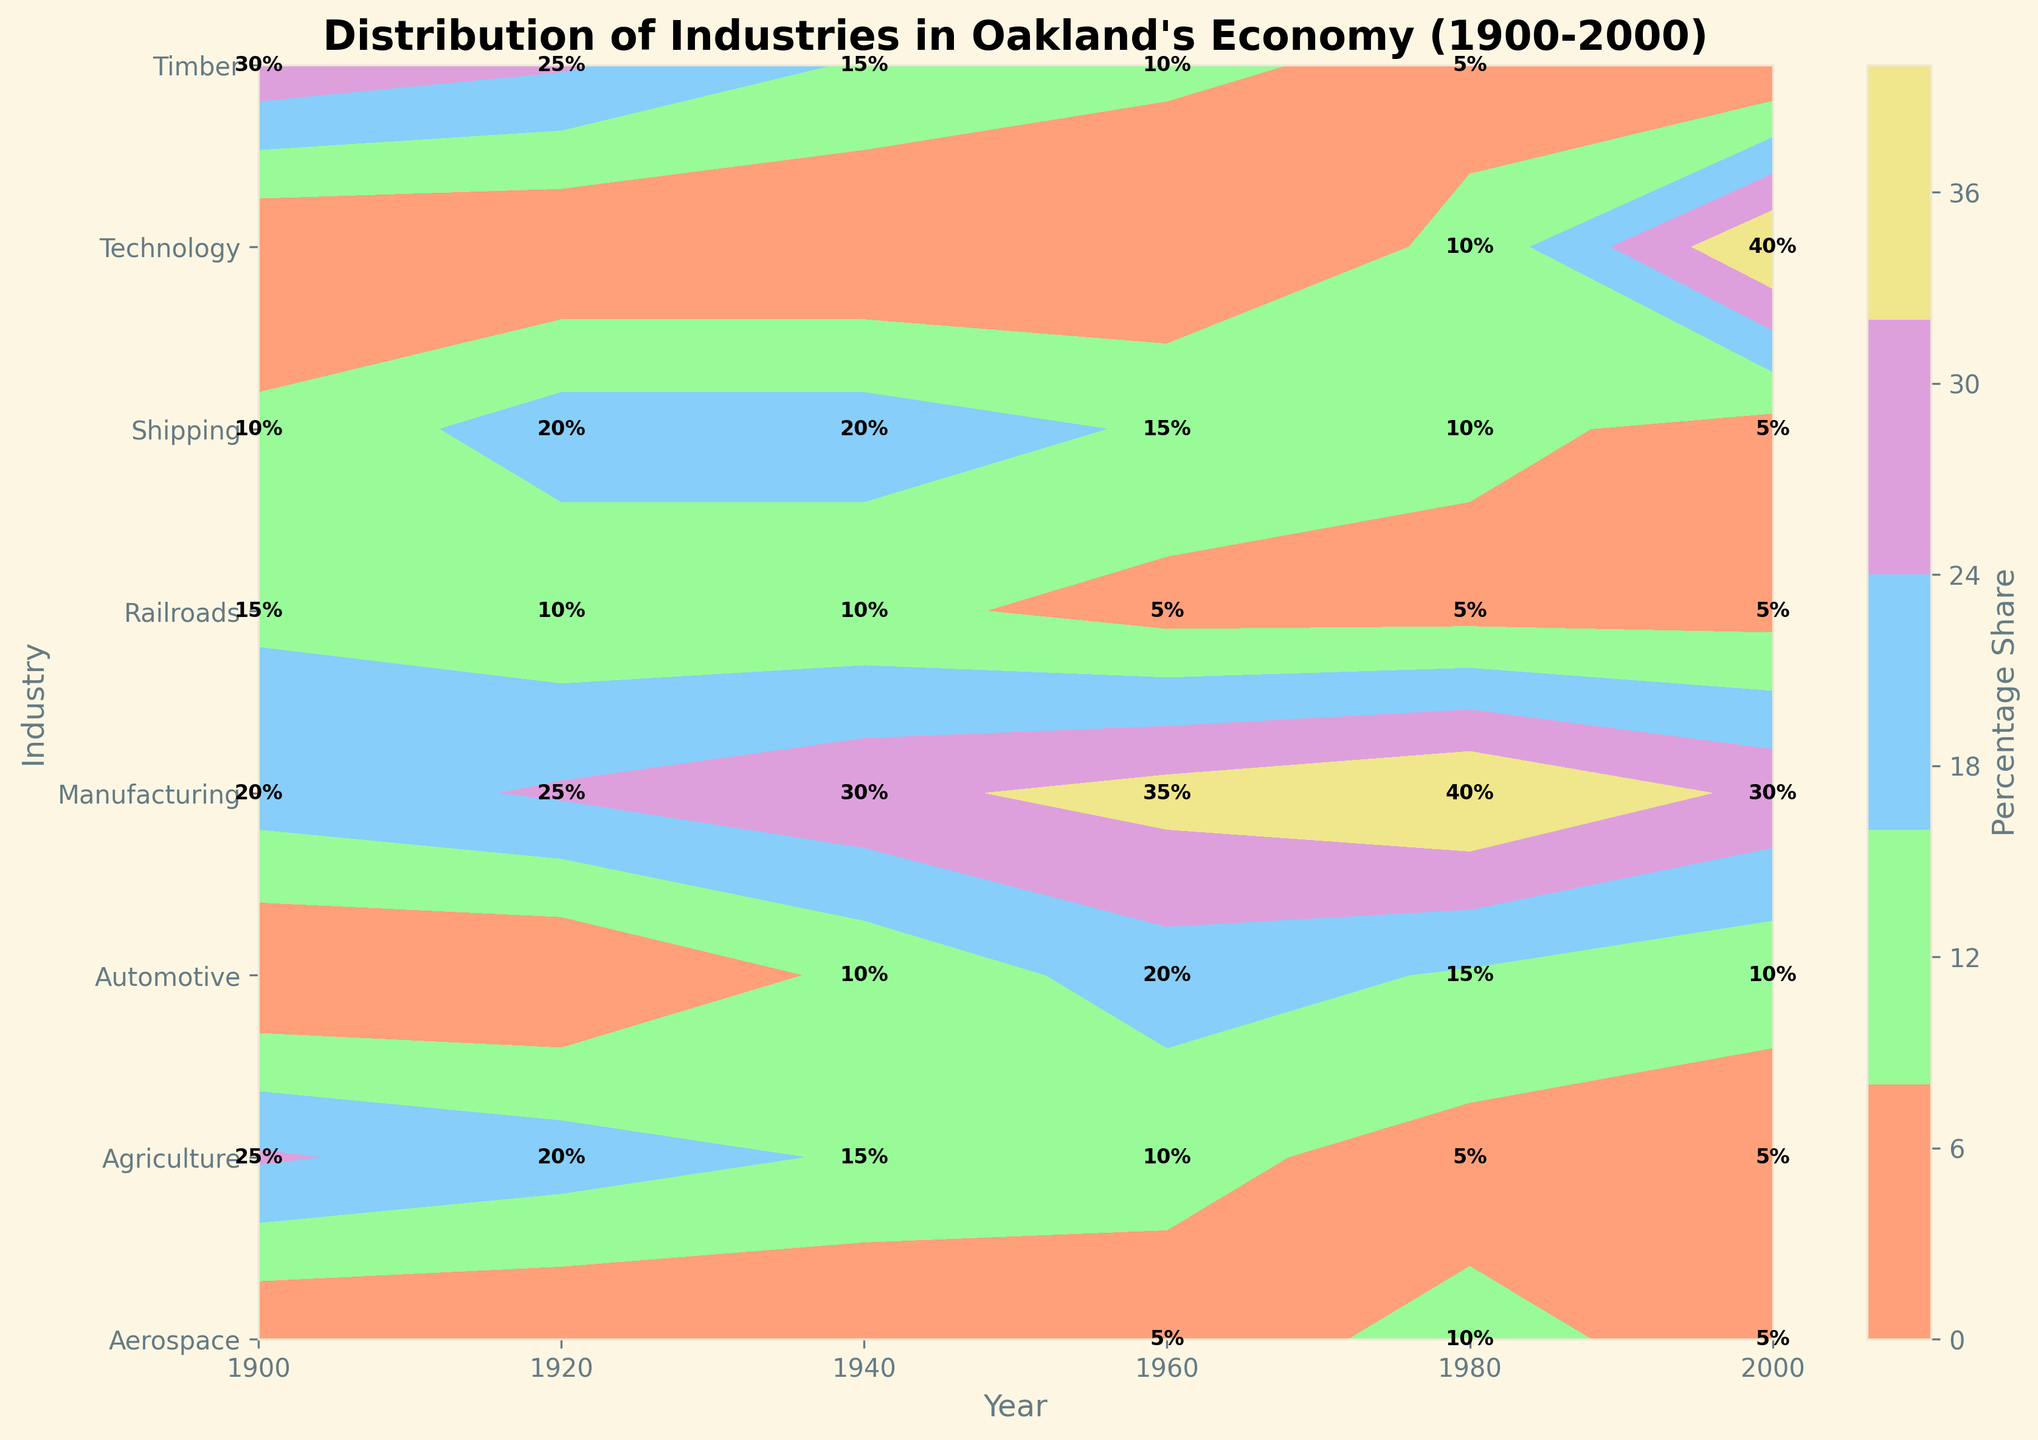What is the title of the plot? The title is displayed at the top of the plot. It is "Distribution of Industries in Oakland's Economy (1900-2000)"
Answer: Distribution of Industries in Oakland's Economy (1900-2000) Which industry had the highest percentage share in 1900? To find the highest percentage share, look at the labels within the contour plot under the year 1900. The industry with the highest value is Timber with 30%
Answer: Timber How did the share of Automotive industry change from 1940 to 2000? Locate values for the Automotive industry in the years 1940 and 2000 within the plot. In 1940, Automotive had a 10% share and in 2000, it had a 10% share, so the share did not change
Answer: No change Which industry had the most considerable increase in its percentage share from 1980 to 2000? Compare the industries listed under 1980 and 2000. The Technology industry shows an increase from 10% in 1980 to 40% in 2000, the most significant rise of 30%
Answer: Technology How did the Agriculture industry's percentage share trend over the 20th century? Track the Agriculture industry's share from 1900 to 2000. The values are 25% (1900), 20% (1920), 15% (1940), 10% (1960), 5% (1980), and 5% (2000). The trend shows a consistent decline
Answer: Decline In which decade did Manufacturing first reach a 30% share? Look at the Manufacturing values over different years. The first year it reached 30% is in 1940
Answer: 1940 Which two industries had exactly the same percentage share in 1960? Examine 1960 values for industries. Both Timber and Agriculture had 10% shares
Answer: Timber and Agriculture By how much did the Timber industry’s share decrease from 1900 to 1980? Check the Timber industry’s share for 1900 and 1980. In 1900, it was 30%, and in 1980 it was 5%. The decrease is 30% - 5% = 25%
Answer: 25% Which industry was absent in 1900 but appeared by 1940? Compare industries between 1900 and 1940. The Automotive industry does not appear in 1900 but appears in 1940 with a 10% share
Answer: Automotive Is there any industry that consistently appeared in the data from 1900 to 2000? Check all industries to see if they have values in every year listed. Manufacturing has values in all years from 1900 to 2000
Answer: Manufacturing 